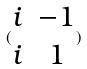Convert formula to latex. <formula><loc_0><loc_0><loc_500><loc_500>( \begin{matrix} i & - 1 \\ i & 1 \end{matrix} )</formula> 